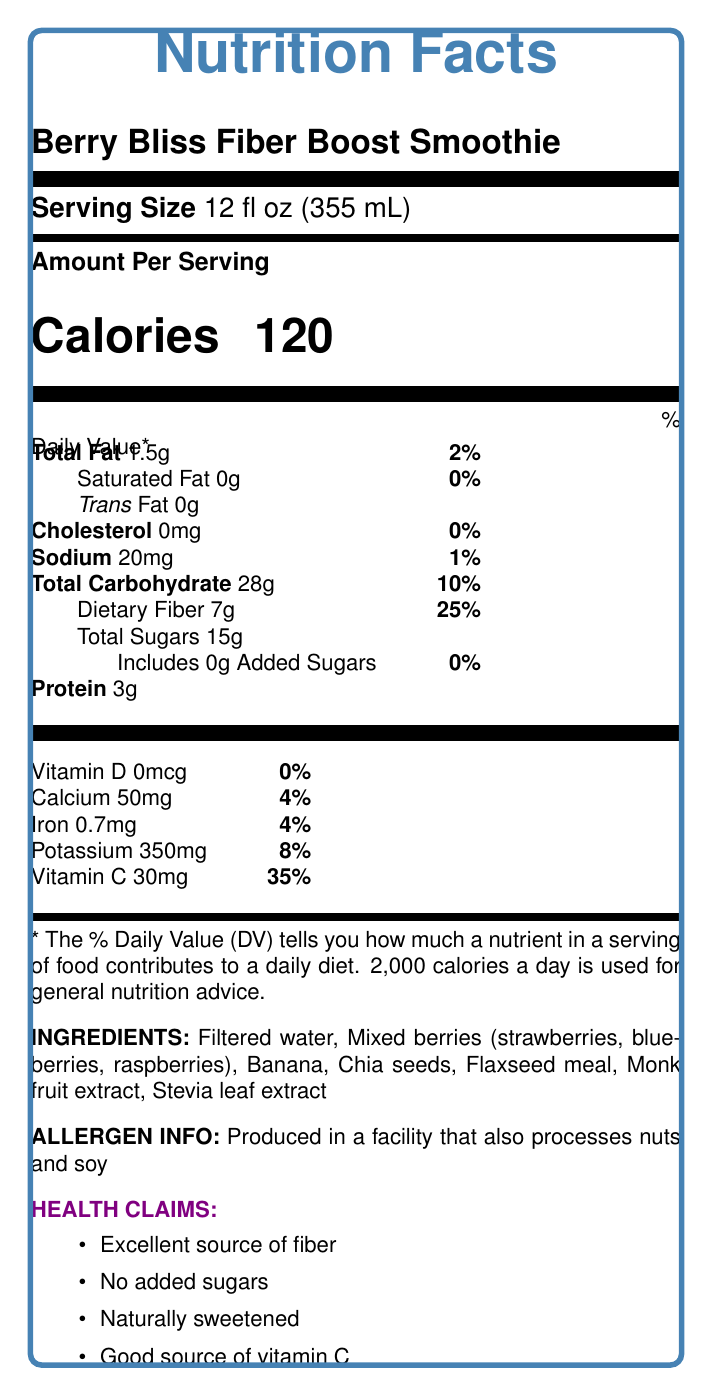what is the serving size of the Berry Bliss Fiber Boost Smoothie? The serving size is clearly specified at the beginning of the document as "Serving Size: 12 fl oz (355 mL)".
Answer: 12 fl oz (355 mL) How many grams of dietary fiber are in one serving? The document lists "Dietary Fiber 7g" under the total carbohydrate section.
Answer: 7g What percentage of the daily value for dietary fiber does one serving provide? It is mentioned next to the dietary fiber amount: "Dietary Fiber 7g, 25%".
Answer: 25% List the natural sweeteners used in the Berry Bliss Fiber Boost Smoothie. The ingredients section lists these natural sweeteners: "Monk fruit extract, Stevia leaf extract".
Answer: Monk fruit extract, Stevia leaf extract What is the total carbohydrate content per serving? The document lists "Total Carbohydrate 28g" with a daily value of 10%.
Answer: 28g Does this smoothie contain any added sugars? The smoothie includes 0g of added sugars as mentioned: "Includes 0g Added Sugars, 0%".
Answer: No How many calories are in one serving of the smoothie? The document clearly states "Calories 120".
Answer: 120 Which nutrient in the smoothie has the highest percentage of the daily value? The vitamin C content is 35% of the daily value, which is the highest among the listed nutrients when compared to others such as dietary fiber (25%) and potassium (8%).
Answer: Vitamin C What is the protein content in one serving of the smoothie? The document states "Protein 3g".
Answer: 3g Multiple-choice: Besides fiber, what other health benefit is highlighted for the Berry Bliss Fiber Boost Smoothie?
A. High protein content
B. Low sodium
C. High vitamin D content
D. High iron content The smoothie is low in sodium, as stated in the dietitian's notes: "Low in sodium, suitable for those monitoring their salt intake".
Answer: B Multiple-choice: Which ingredient is NOT part of the Berry Bliss Fiber Boost Smoothie?
1. Chia seeds
2. Bananas
3. Honey
4. Blueberries Honey is not listed among the ingredients, while chia seeds, bananas, and blueberries are.
Answer: 3 Is this smoothie a good source of omega-3 fatty acids? According to the dietitian's notes, flaxseed meal and chia seeds, which are ingredients in the smoothie, provide omega-3 fatty acids.
Answer: Yes Summary question: Describe the main nutritional highlights of the Berry Bliss Fiber Boost Smoothie. The description covers the core nutritional benefits and ingredient highlights as laid out in the document.
Answer: The Berry Bliss Fiber Boost Smoothie is a low-sugar, fiber-rich beverage with no added sugars and natural sweeteners like monk fruit and stevia. It contains 120 calories per serving, 7g of dietary fiber that accounts for 25% of the daily value, and 15g of natural sugars from fruits. The smoothie is also a good source of vitamin C (35% DV). Besides fiber, it offers antioxidants from berries, omega-3 fatty acids from flaxseed meal and chia seeds, and is low in sodium. What is the sodium content of the smoothie? The sodium content per serving is listed as "Sodium 20mg".
Answer: 20mg How much calcium does one serving provide? One serving contains 50mg of calcium, which is 4% of the daily value.
Answer: 50mg Can this smoothie be considered gluten-free based on the provided information? There is no explicit information provided in the document about the gluten content or gluten-free certification. The allergen info only references nuts and soy.
Answer: Not enough information 